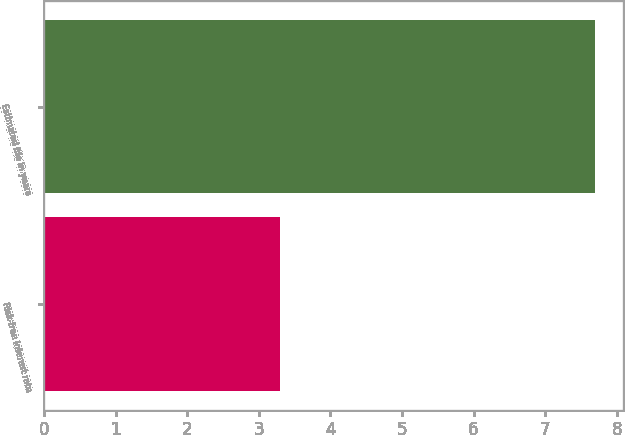<chart> <loc_0><loc_0><loc_500><loc_500><bar_chart><fcel>Risk-free interest rate<fcel>Estimated life in years<nl><fcel>3.3<fcel>7.7<nl></chart> 